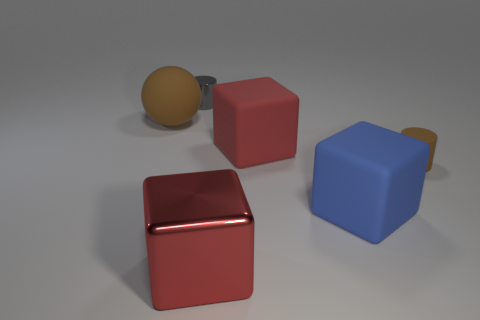Subtract 1 blocks. How many blocks are left? 2 Subtract all yellow cylinders. How many red cubes are left? 2 Subtract all red blocks. How many blocks are left? 1 Add 3 big red cubes. How many objects exist? 9 Subtract all cylinders. How many objects are left? 4 Subtract all large cyan cylinders. Subtract all small gray shiny cylinders. How many objects are left? 5 Add 4 large red blocks. How many large red blocks are left? 6 Add 1 big red cubes. How many big red cubes exist? 3 Subtract 0 blue cylinders. How many objects are left? 6 